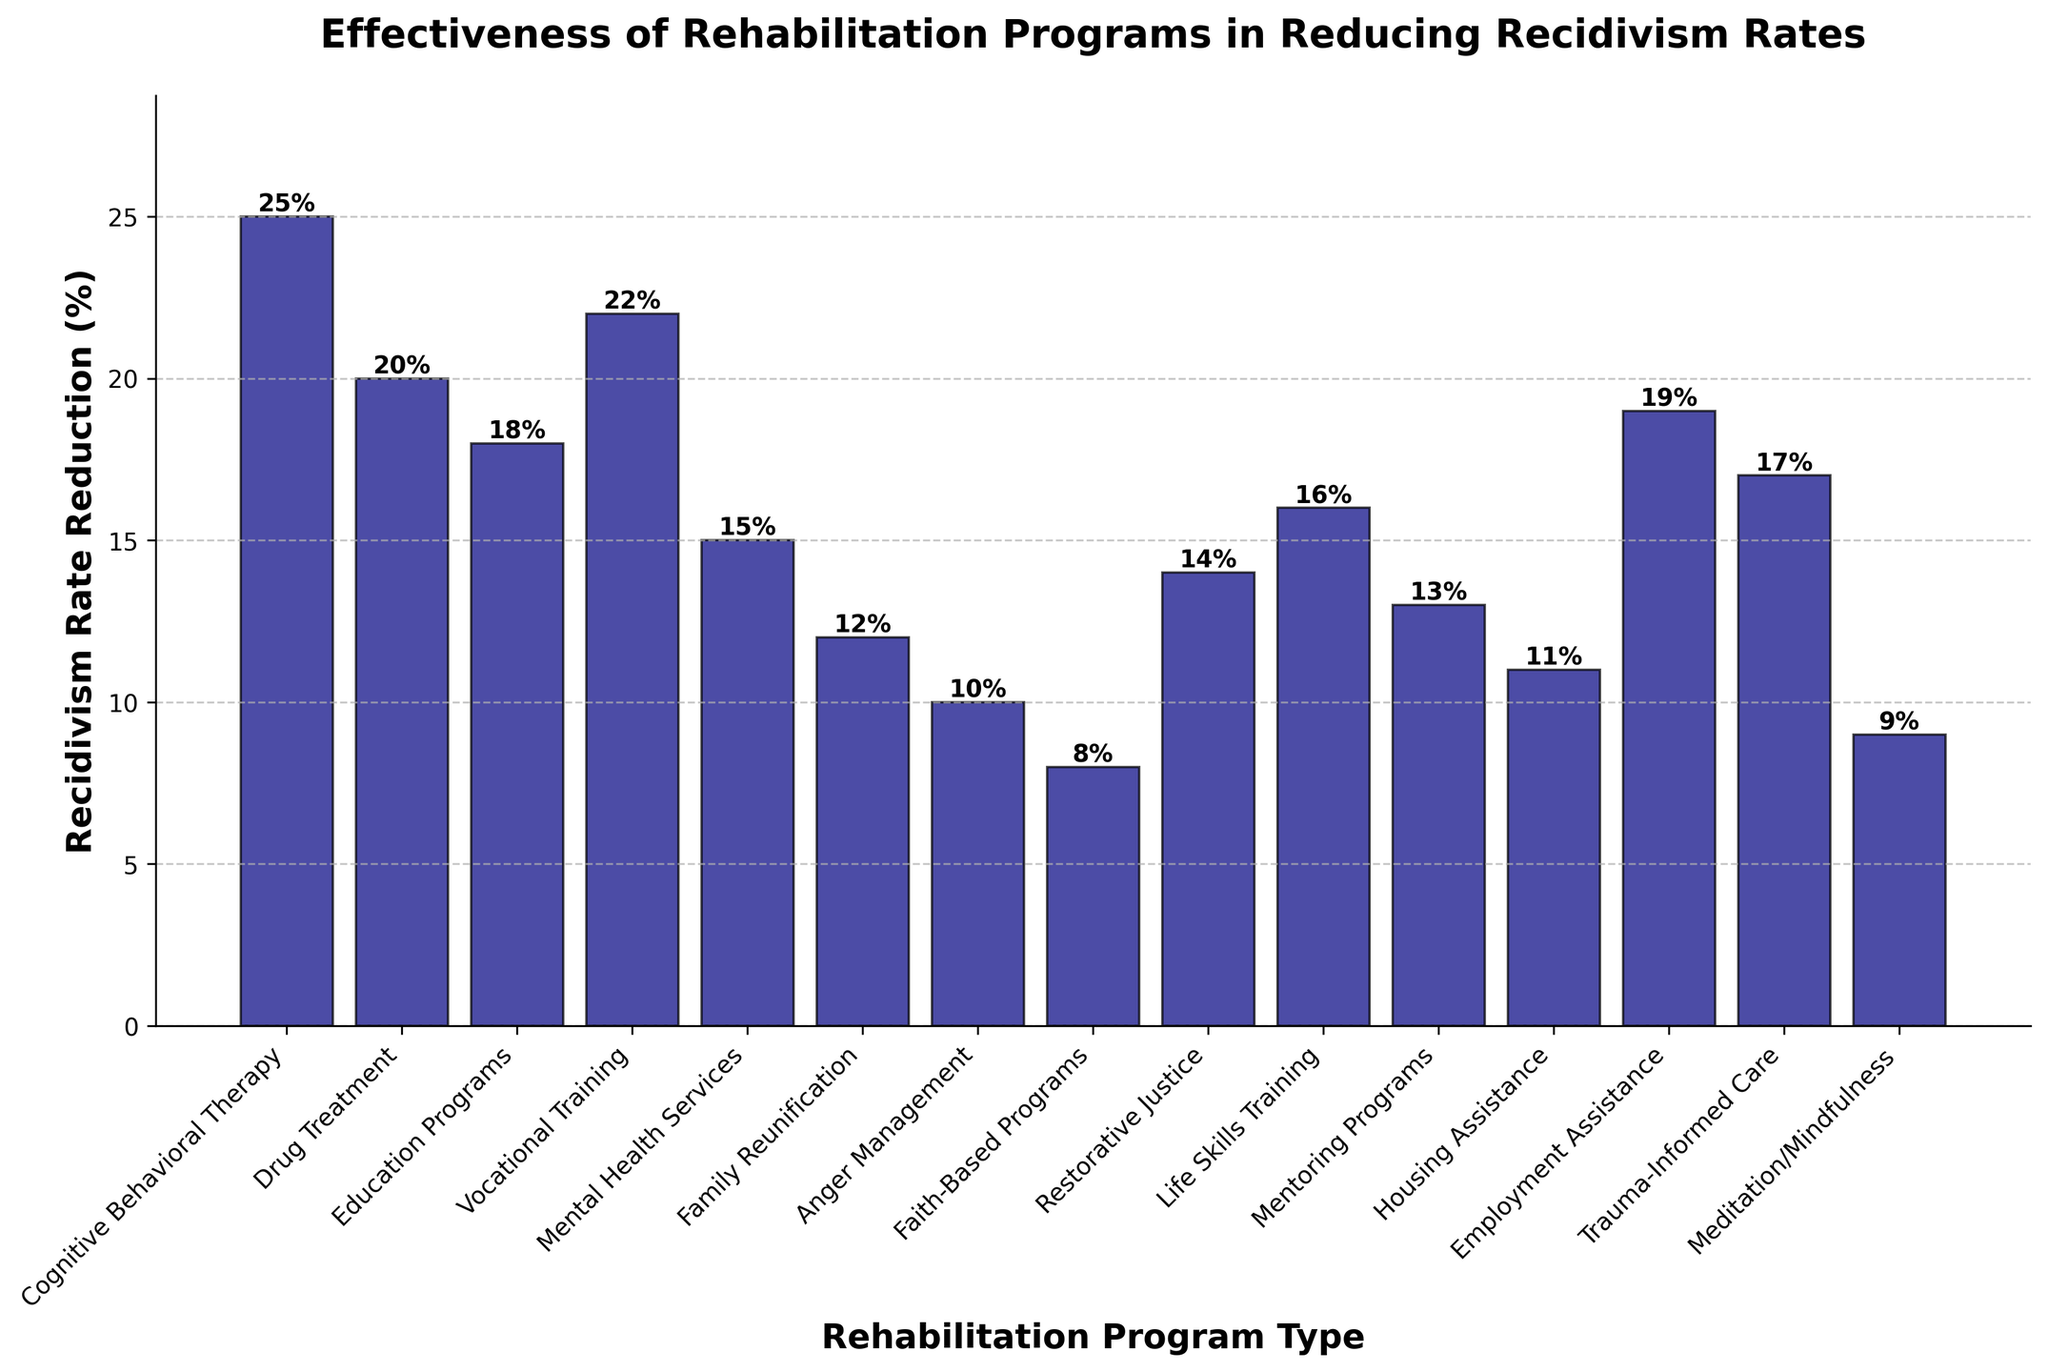Which program shows the highest reduction in recidivism rates? The tallest bar in the chart represents the program with the highest reduction. The "Cognitive Behavioral Therapy" bar is the tallest, indicating it has the highest reduction percentage.
Answer: Cognitive Behavioral Therapy What is the difference in recidivism rate reduction between Drug Treatment and Vocational Training? The bar for Drug Treatment shows a reduction of 20%, and the bar for Vocational Training shows a reduction of 22%. The difference is calculated by subtracting 20 from 22.
Answer: 2% Which program shows a lower reduction in recidivism rates, Family Reunification or Housing Assistance? Compare the height of the bars for Family Reunification and Housing Assistance. Family Reunification shows a reduction of 12%, while Housing Assistance shows a reduction of 11%.
Answer: Housing Assistance What is the average recidivism rate reduction for Mental Health Services, Restorative Justice, and Mentoring Programs? Add the reductions for the three programs (15% for Mental Health Services, 14% for Restorative Justice, and 13% for Mentoring Programs), then divide by 3. (15 + 14 + 13) / 3 = 14%
Answer: 14% Which programs have a reduction rate greater than 15% but less than 20%? Identify the bars within the range of 15% to 20%. Vocational Training (22%), Life Skills Training (16%), and Employment Assistance (19%) fall within this range.
Answer: Life Skills Training, Employment Assistance What is the combined recidivism rate reduction for the three least effective programs shown? The three least effective programs based on the figure are the ones with the shortest bars: Faith-Based Programs (8%), Meditation/Mindfulness (9%), and Anger Management (10%). Combine their reductions: 8% + 9% + 10% = 27%
Answer: 27% Which program types are shown in the figure to have a reduction rate exactly equal to 12%? Look for bars that exactly reach 12%. The Family Reunification bar is the one that matches this criterion.
Answer: Family Reunification What is the overall total reduction rate when combining Education Programs and Trauma-Informed Care? Combine the reduction percentages for Education Programs (18%) and Trauma-Informed Care (17%). 18% + 17% = 35%
Answer: 35% How does Meditation/Mindfulness compare to Cognitive Behavioral Therapy in terms of reduction rate percentage? Compare the height of the bars for Meditation/Mindfulness (9%) and Cognitive Behavioral Therapy (25%). Meditation/Mindfulness has a significantly lower reduction rate percentage.
Answer: Cognitive Behavioral Therapy is much higher 